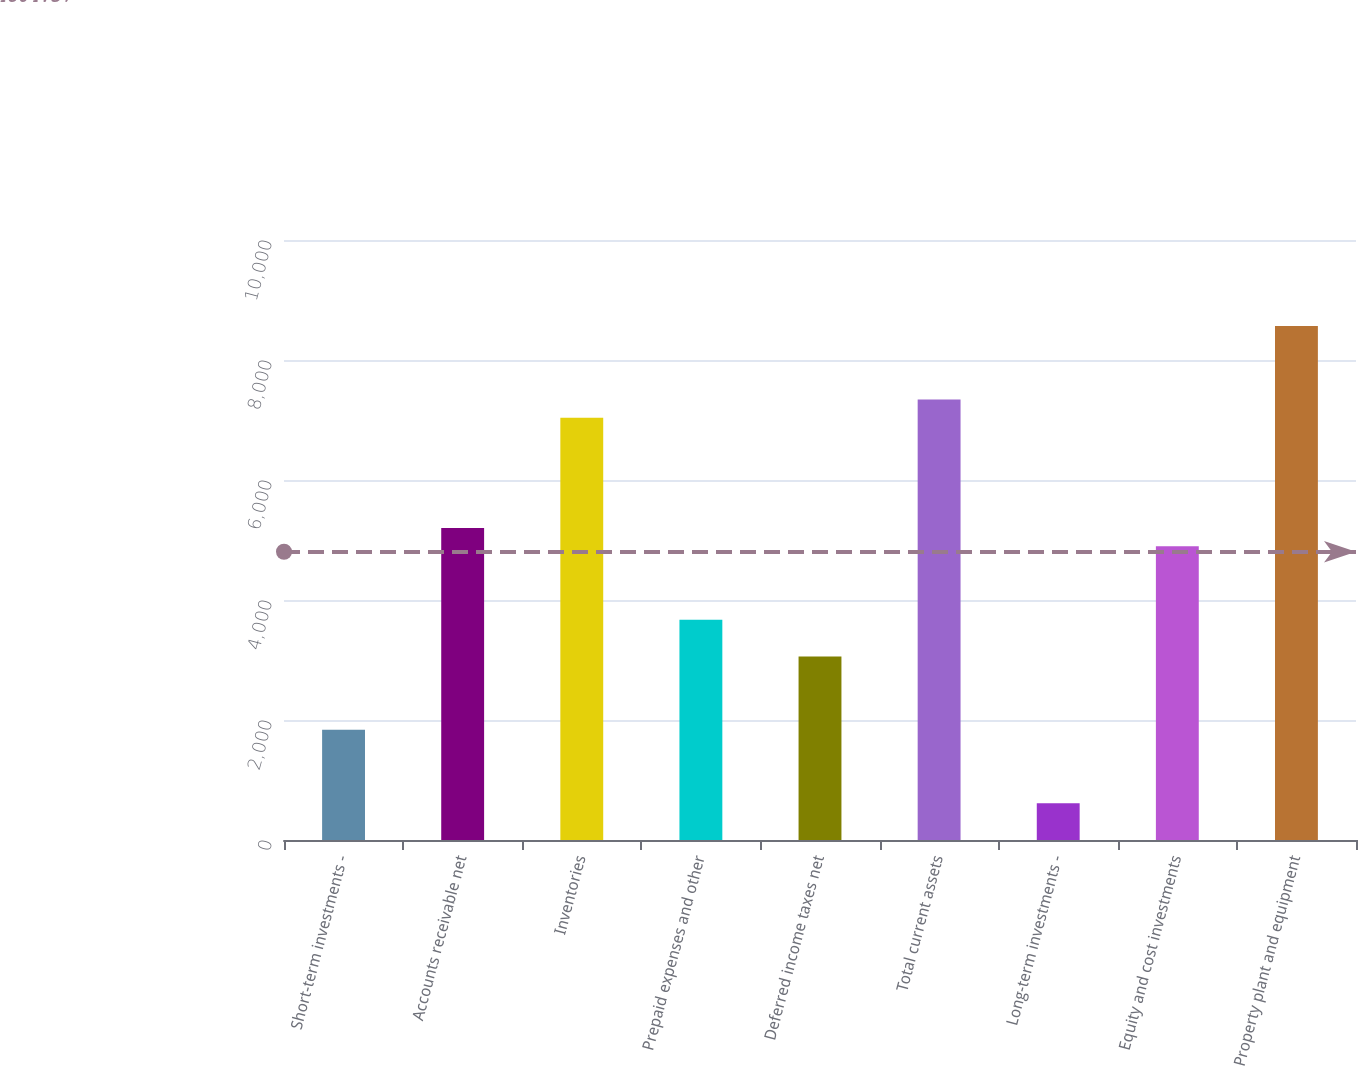<chart> <loc_0><loc_0><loc_500><loc_500><bar_chart><fcel>Short-term investments -<fcel>Accounts receivable net<fcel>Inventories<fcel>Prepaid expenses and other<fcel>Deferred income taxes net<fcel>Total current assets<fcel>Long-term investments -<fcel>Equity and cost investments<fcel>Property plant and equipment<nl><fcel>1836.16<fcel>5201.17<fcel>7036.63<fcel>3671.62<fcel>3059.8<fcel>7342.54<fcel>612.52<fcel>4895.26<fcel>8566.18<nl></chart> 